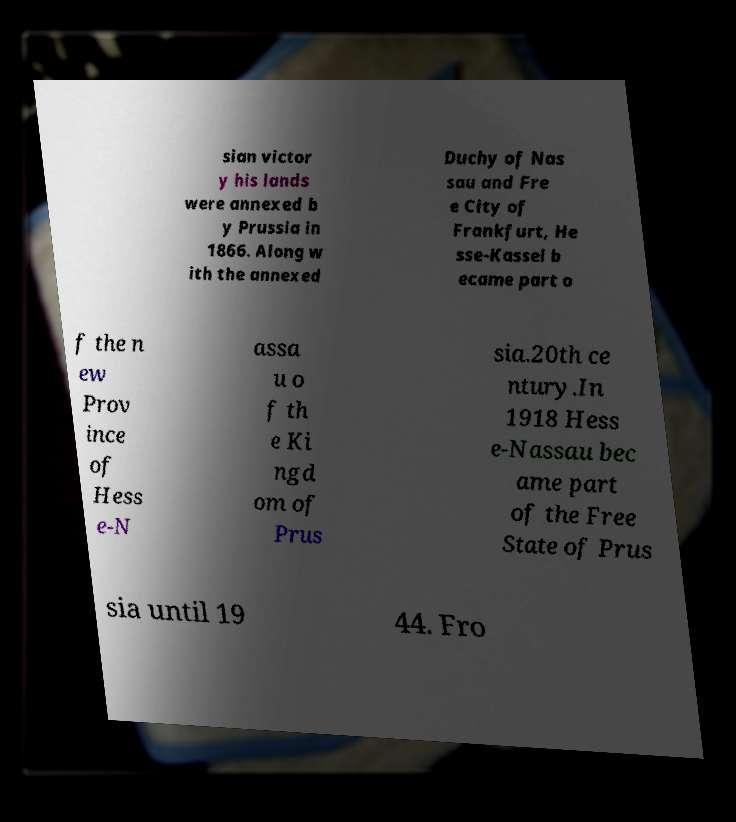What messages or text are displayed in this image? I need them in a readable, typed format. sian victor y his lands were annexed b y Prussia in 1866. Along w ith the annexed Duchy of Nas sau and Fre e City of Frankfurt, He sse-Kassel b ecame part o f the n ew Prov ince of Hess e-N assa u o f th e Ki ngd om of Prus sia.20th ce ntury.In 1918 Hess e-Nassau bec ame part of the Free State of Prus sia until 19 44. Fro 